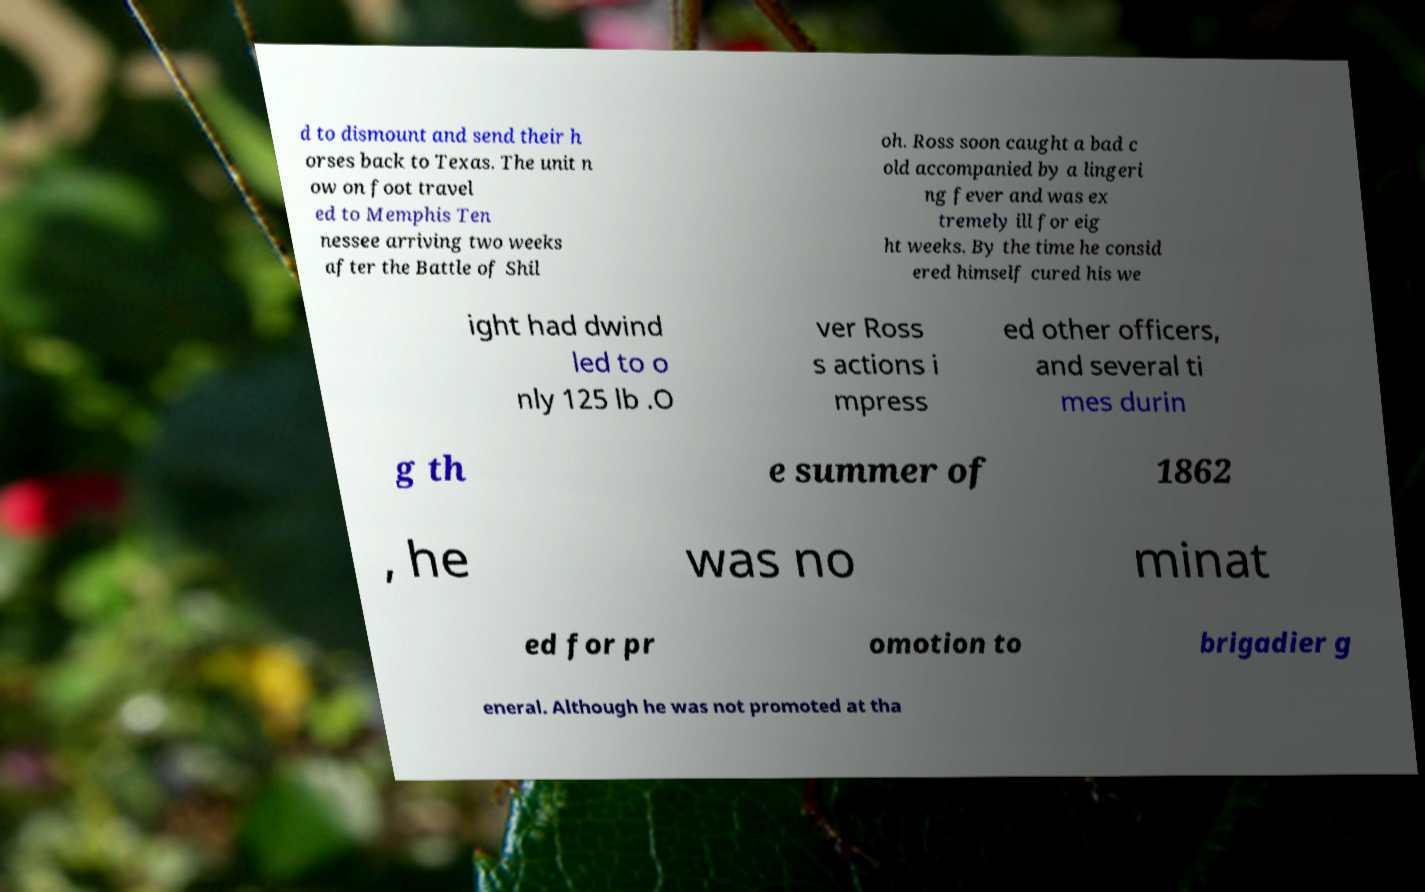I need the written content from this picture converted into text. Can you do that? d to dismount and send their h orses back to Texas. The unit n ow on foot travel ed to Memphis Ten nessee arriving two weeks after the Battle of Shil oh. Ross soon caught a bad c old accompanied by a lingeri ng fever and was ex tremely ill for eig ht weeks. By the time he consid ered himself cured his we ight had dwind led to o nly 125 lb .O ver Ross s actions i mpress ed other officers, and several ti mes durin g th e summer of 1862 , he was no minat ed for pr omotion to brigadier g eneral. Although he was not promoted at tha 